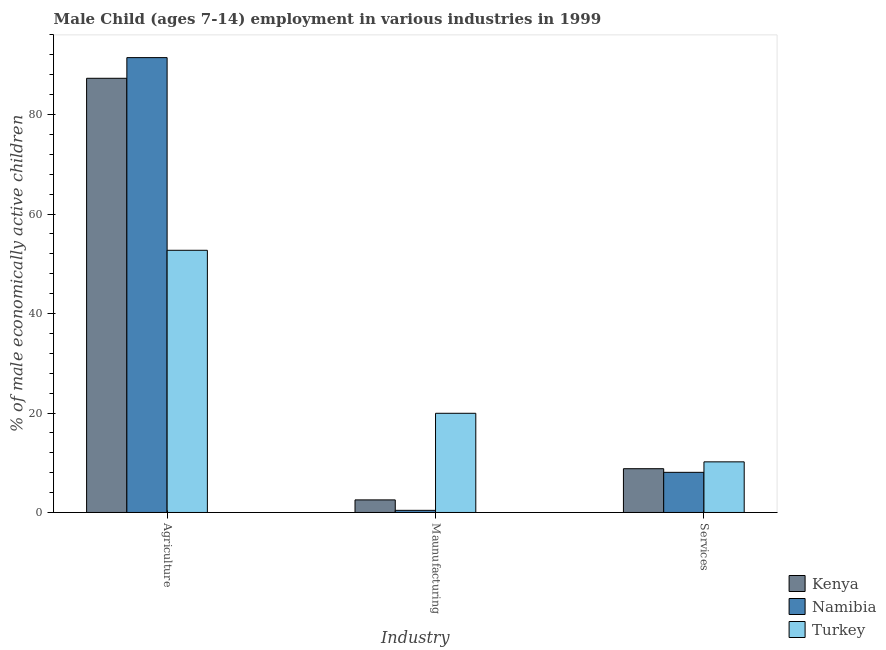How many different coloured bars are there?
Provide a short and direct response. 3. How many groups of bars are there?
Provide a succinct answer. 3. Are the number of bars per tick equal to the number of legend labels?
Offer a terse response. Yes. How many bars are there on the 1st tick from the right?
Offer a very short reply. 3. What is the label of the 2nd group of bars from the left?
Make the answer very short. Maunufacturing. What is the percentage of economically active children in agriculture in Kenya?
Keep it short and to the point. 87.29. Across all countries, what is the maximum percentage of economically active children in services?
Offer a terse response. 10.18. Across all countries, what is the minimum percentage of economically active children in agriculture?
Ensure brevity in your answer.  52.71. In which country was the percentage of economically active children in services maximum?
Your response must be concise. Turkey. What is the total percentage of economically active children in agriculture in the graph?
Your response must be concise. 231.46. What is the difference between the percentage of economically active children in agriculture in Turkey and that in Kenya?
Make the answer very short. -34.58. What is the difference between the percentage of economically active children in agriculture in Namibia and the percentage of economically active children in services in Turkey?
Your answer should be compact. 81.27. What is the average percentage of economically active children in manufacturing per country?
Provide a succinct answer. 7.63. What is the difference between the percentage of economically active children in agriculture and percentage of economically active children in services in Turkey?
Your answer should be very brief. 42.53. In how many countries, is the percentage of economically active children in agriculture greater than 64 %?
Ensure brevity in your answer.  2. What is the ratio of the percentage of economically active children in agriculture in Kenya to that in Turkey?
Your answer should be very brief. 1.66. Is the difference between the percentage of economically active children in manufacturing in Namibia and Turkey greater than the difference between the percentage of economically active children in agriculture in Namibia and Turkey?
Offer a terse response. No. What is the difference between the highest and the second highest percentage of economically active children in services?
Ensure brevity in your answer.  1.38. What is the difference between the highest and the lowest percentage of economically active children in services?
Your answer should be very brief. 2.11. Is the sum of the percentage of economically active children in services in Namibia and Kenya greater than the maximum percentage of economically active children in agriculture across all countries?
Provide a short and direct response. No. What does the 1st bar from the left in Agriculture represents?
Keep it short and to the point. Kenya. What does the 2nd bar from the right in Maunufacturing represents?
Your response must be concise. Namibia. Is it the case that in every country, the sum of the percentage of economically active children in agriculture and percentage of economically active children in manufacturing is greater than the percentage of economically active children in services?
Your response must be concise. Yes. How many bars are there?
Provide a succinct answer. 9. Are all the bars in the graph horizontal?
Offer a very short reply. No. Does the graph contain any zero values?
Your response must be concise. No. Where does the legend appear in the graph?
Your response must be concise. Bottom right. What is the title of the graph?
Offer a terse response. Male Child (ages 7-14) employment in various industries in 1999. Does "Namibia" appear as one of the legend labels in the graph?
Your answer should be compact. Yes. What is the label or title of the X-axis?
Your answer should be compact. Industry. What is the label or title of the Y-axis?
Your answer should be very brief. % of male economically active children. What is the % of male economically active children of Kenya in Agriculture?
Your response must be concise. 87.29. What is the % of male economically active children in Namibia in Agriculture?
Offer a very short reply. 91.45. What is the % of male economically active children of Turkey in Agriculture?
Offer a terse response. 52.71. What is the % of male economically active children in Kenya in Maunufacturing?
Your answer should be compact. 2.53. What is the % of male economically active children of Namibia in Maunufacturing?
Provide a succinct answer. 0.43. What is the % of male economically active children of Turkey in Maunufacturing?
Give a very brief answer. 19.94. What is the % of male economically active children of Kenya in Services?
Offer a very short reply. 8.8. What is the % of male economically active children of Namibia in Services?
Your response must be concise. 8.07. What is the % of male economically active children in Turkey in Services?
Offer a very short reply. 10.18. Across all Industry, what is the maximum % of male economically active children of Kenya?
Provide a succinct answer. 87.29. Across all Industry, what is the maximum % of male economically active children in Namibia?
Provide a short and direct response. 91.45. Across all Industry, what is the maximum % of male economically active children in Turkey?
Provide a succinct answer. 52.71. Across all Industry, what is the minimum % of male economically active children in Kenya?
Your answer should be compact. 2.53. Across all Industry, what is the minimum % of male economically active children of Namibia?
Keep it short and to the point. 0.43. Across all Industry, what is the minimum % of male economically active children of Turkey?
Give a very brief answer. 10.18. What is the total % of male economically active children in Kenya in the graph?
Your answer should be very brief. 98.62. What is the total % of male economically active children of Namibia in the graph?
Make the answer very short. 99.95. What is the total % of male economically active children in Turkey in the graph?
Provide a succinct answer. 82.83. What is the difference between the % of male economically active children of Kenya in Agriculture and that in Maunufacturing?
Offer a terse response. 84.76. What is the difference between the % of male economically active children of Namibia in Agriculture and that in Maunufacturing?
Give a very brief answer. 91.02. What is the difference between the % of male economically active children of Turkey in Agriculture and that in Maunufacturing?
Make the answer very short. 32.77. What is the difference between the % of male economically active children in Kenya in Agriculture and that in Services?
Provide a short and direct response. 78.49. What is the difference between the % of male economically active children in Namibia in Agriculture and that in Services?
Your response must be concise. 83.38. What is the difference between the % of male economically active children in Turkey in Agriculture and that in Services?
Make the answer very short. 42.53. What is the difference between the % of male economically active children in Kenya in Maunufacturing and that in Services?
Provide a succinct answer. -6.27. What is the difference between the % of male economically active children of Namibia in Maunufacturing and that in Services?
Ensure brevity in your answer.  -7.64. What is the difference between the % of male economically active children of Turkey in Maunufacturing and that in Services?
Make the answer very short. 9.77. What is the difference between the % of male economically active children in Kenya in Agriculture and the % of male economically active children in Namibia in Maunufacturing?
Provide a succinct answer. 86.86. What is the difference between the % of male economically active children of Kenya in Agriculture and the % of male economically active children of Turkey in Maunufacturing?
Offer a terse response. 67.35. What is the difference between the % of male economically active children of Namibia in Agriculture and the % of male economically active children of Turkey in Maunufacturing?
Your answer should be very brief. 71.51. What is the difference between the % of male economically active children in Kenya in Agriculture and the % of male economically active children in Namibia in Services?
Your response must be concise. 79.22. What is the difference between the % of male economically active children in Kenya in Agriculture and the % of male economically active children in Turkey in Services?
Make the answer very short. 77.12. What is the difference between the % of male economically active children of Namibia in Agriculture and the % of male economically active children of Turkey in Services?
Your answer should be compact. 81.27. What is the difference between the % of male economically active children in Kenya in Maunufacturing and the % of male economically active children in Namibia in Services?
Your answer should be compact. -5.54. What is the difference between the % of male economically active children of Kenya in Maunufacturing and the % of male economically active children of Turkey in Services?
Your response must be concise. -7.65. What is the difference between the % of male economically active children in Namibia in Maunufacturing and the % of male economically active children in Turkey in Services?
Ensure brevity in your answer.  -9.75. What is the average % of male economically active children of Kenya per Industry?
Keep it short and to the point. 32.87. What is the average % of male economically active children of Namibia per Industry?
Your response must be concise. 33.32. What is the average % of male economically active children of Turkey per Industry?
Keep it short and to the point. 27.61. What is the difference between the % of male economically active children of Kenya and % of male economically active children of Namibia in Agriculture?
Your response must be concise. -4.16. What is the difference between the % of male economically active children of Kenya and % of male economically active children of Turkey in Agriculture?
Offer a very short reply. 34.58. What is the difference between the % of male economically active children of Namibia and % of male economically active children of Turkey in Agriculture?
Provide a succinct answer. 38.74. What is the difference between the % of male economically active children of Kenya and % of male economically active children of Namibia in Maunufacturing?
Your response must be concise. 2.1. What is the difference between the % of male economically active children in Kenya and % of male economically active children in Turkey in Maunufacturing?
Give a very brief answer. -17.41. What is the difference between the % of male economically active children in Namibia and % of male economically active children in Turkey in Maunufacturing?
Provide a short and direct response. -19.51. What is the difference between the % of male economically active children of Kenya and % of male economically active children of Namibia in Services?
Offer a very short reply. 0.73. What is the difference between the % of male economically active children in Kenya and % of male economically active children in Turkey in Services?
Keep it short and to the point. -1.38. What is the difference between the % of male economically active children in Namibia and % of male economically active children in Turkey in Services?
Give a very brief answer. -2.11. What is the ratio of the % of male economically active children in Kenya in Agriculture to that in Maunufacturing?
Provide a succinct answer. 34.51. What is the ratio of the % of male economically active children in Namibia in Agriculture to that in Maunufacturing?
Give a very brief answer. 212.67. What is the ratio of the % of male economically active children of Turkey in Agriculture to that in Maunufacturing?
Provide a short and direct response. 2.64. What is the ratio of the % of male economically active children of Kenya in Agriculture to that in Services?
Offer a terse response. 9.92. What is the ratio of the % of male economically active children in Namibia in Agriculture to that in Services?
Your response must be concise. 11.33. What is the ratio of the % of male economically active children in Turkey in Agriculture to that in Services?
Your answer should be very brief. 5.18. What is the ratio of the % of male economically active children of Kenya in Maunufacturing to that in Services?
Provide a short and direct response. 0.29. What is the ratio of the % of male economically active children of Namibia in Maunufacturing to that in Services?
Provide a succinct answer. 0.05. What is the ratio of the % of male economically active children in Turkey in Maunufacturing to that in Services?
Your response must be concise. 1.96. What is the difference between the highest and the second highest % of male economically active children in Kenya?
Ensure brevity in your answer.  78.49. What is the difference between the highest and the second highest % of male economically active children of Namibia?
Your answer should be compact. 83.38. What is the difference between the highest and the second highest % of male economically active children in Turkey?
Your answer should be compact. 32.77. What is the difference between the highest and the lowest % of male economically active children of Kenya?
Provide a short and direct response. 84.76. What is the difference between the highest and the lowest % of male economically active children of Namibia?
Your answer should be very brief. 91.02. What is the difference between the highest and the lowest % of male economically active children of Turkey?
Offer a terse response. 42.53. 